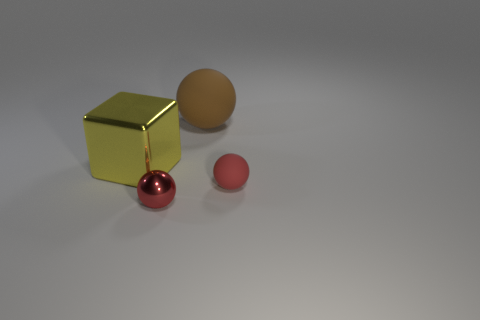Subtract all tiny metallic spheres. How many spheres are left? 2 Subtract all red spheres. How many spheres are left? 1 Add 3 tiny cyan metal balls. How many objects exist? 7 Subtract all spheres. How many objects are left? 1 Subtract all cyan cubes. Subtract all blue spheres. How many cubes are left? 1 Subtract all cyan balls. How many purple cubes are left? 0 Subtract all small red metallic spheres. Subtract all large red blocks. How many objects are left? 3 Add 1 big yellow objects. How many big yellow objects are left? 2 Add 4 brown shiny things. How many brown shiny things exist? 4 Subtract 0 brown blocks. How many objects are left? 4 